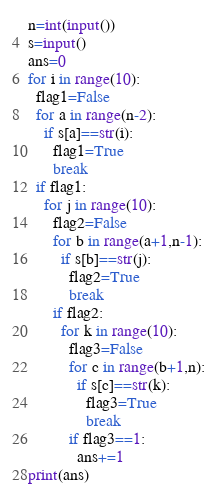<code> <loc_0><loc_0><loc_500><loc_500><_Python_>n=int(input())
s=input()
ans=0
for i in range(10):
  flag1=False
  for a in range(n-2):
    if s[a]==str(i):
      flag1=True
      break
  if flag1:
    for j in range(10):
      flag2=False
      for b in range(a+1,n-1):
        if s[b]==str(j):
          flag2=True
          break
      if flag2:
        for k in range(10):
          flag3=False
          for c in range(b+1,n):
            if s[c]==str(k):
              flag3=True
              break
          if flag3==1:
            ans+=1
print(ans)</code> 